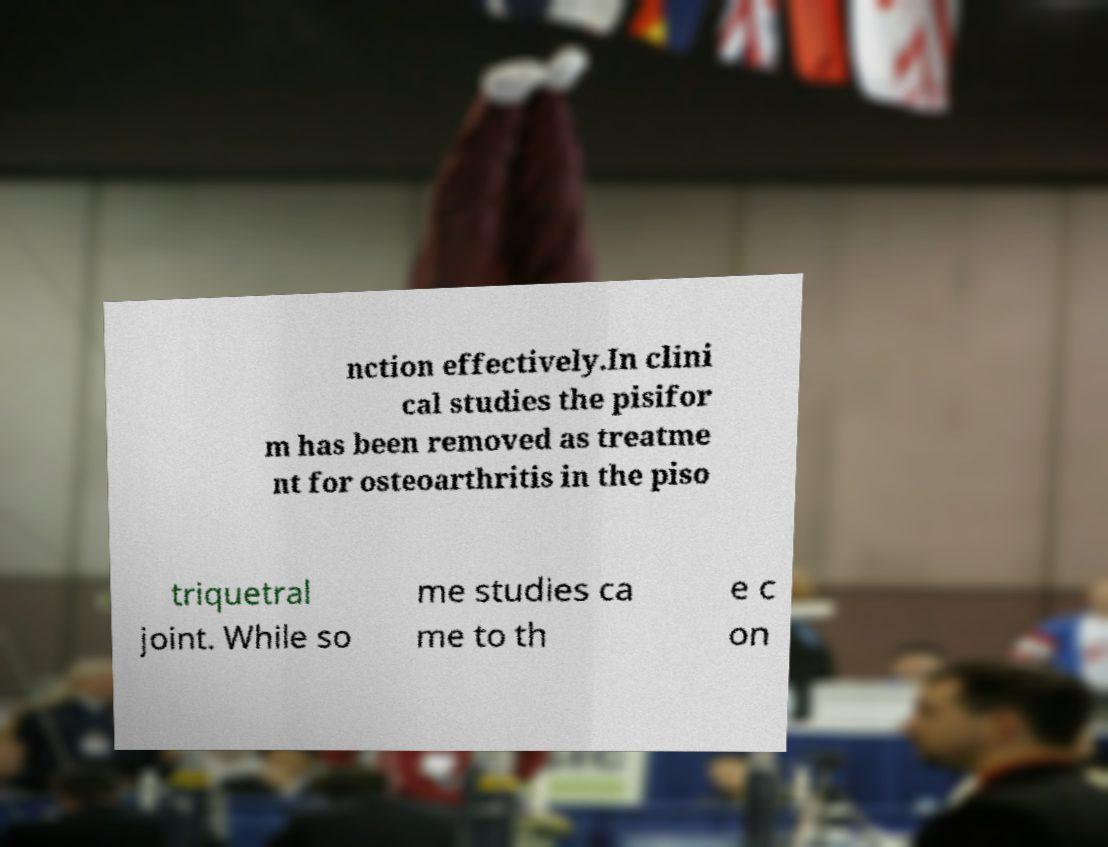There's text embedded in this image that I need extracted. Can you transcribe it verbatim? nction effectively.In clini cal studies the pisifor m has been removed as treatme nt for osteoarthritis in the piso triquetral joint. While so me studies ca me to th e c on 